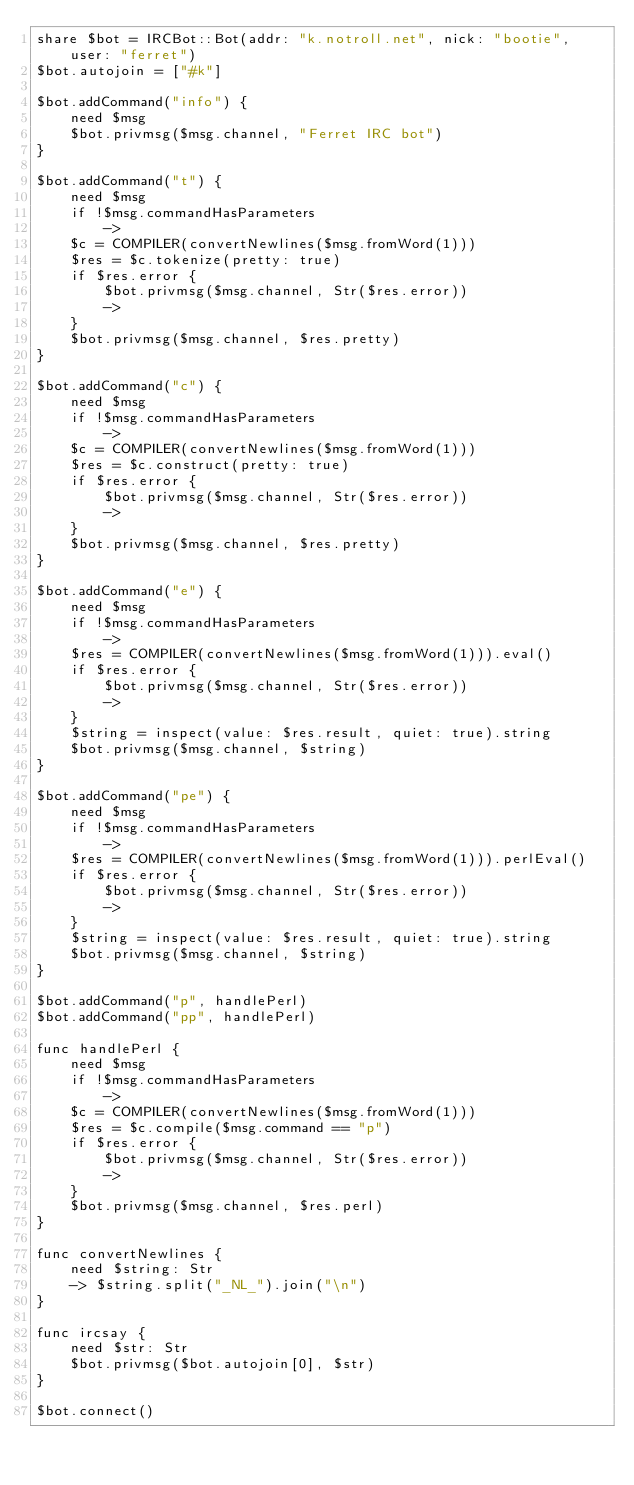<code> <loc_0><loc_0><loc_500><loc_500><_Forth_>share $bot = IRCBot::Bot(addr: "k.notroll.net", nick: "bootie", user: "ferret")
$bot.autojoin = ["#k"]

$bot.addCommand("info") {
    need $msg
    $bot.privmsg($msg.channel, "Ferret IRC bot")
}

$bot.addCommand("t") {
    need $msg
    if !$msg.commandHasParameters
        ->
    $c = COMPILER(convertNewlines($msg.fromWord(1)))
    $res = $c.tokenize(pretty: true)
    if $res.error {
        $bot.privmsg($msg.channel, Str($res.error))
        ->
    }
    $bot.privmsg($msg.channel, $res.pretty)
}

$bot.addCommand("c") {
    need $msg
    if !$msg.commandHasParameters
        ->
    $c = COMPILER(convertNewlines($msg.fromWord(1)))
    $res = $c.construct(pretty: true)
    if $res.error {
        $bot.privmsg($msg.channel, Str($res.error))
        ->
    }
    $bot.privmsg($msg.channel, $res.pretty)
}

$bot.addCommand("e") {
    need $msg
    if !$msg.commandHasParameters
        ->
    $res = COMPILER(convertNewlines($msg.fromWord(1))).eval()
    if $res.error {
        $bot.privmsg($msg.channel, Str($res.error))
        ->
    }
    $string = inspect(value: $res.result, quiet: true).string
    $bot.privmsg($msg.channel, $string)
}

$bot.addCommand("pe") {
    need $msg
    if !$msg.commandHasParameters
        ->
    $res = COMPILER(convertNewlines($msg.fromWord(1))).perlEval()
    if $res.error {
        $bot.privmsg($msg.channel, Str($res.error))
        ->
    }
    $string = inspect(value: $res.result, quiet: true).string
    $bot.privmsg($msg.channel, $string)
}

$bot.addCommand("p", handlePerl)
$bot.addCommand("pp", handlePerl)

func handlePerl {
    need $msg
    if !$msg.commandHasParameters
        ->
    $c = COMPILER(convertNewlines($msg.fromWord(1)))
    $res = $c.compile($msg.command == "p")
    if $res.error {
        $bot.privmsg($msg.channel, Str($res.error))
        ->
    }
    $bot.privmsg($msg.channel, $res.perl)
}

func convertNewlines {
    need $string: Str
    -> $string.split("_NL_").join("\n")
}

func ircsay {
    need $str: Str
    $bot.privmsg($bot.autojoin[0], $str)
}

$bot.connect()
</code> 